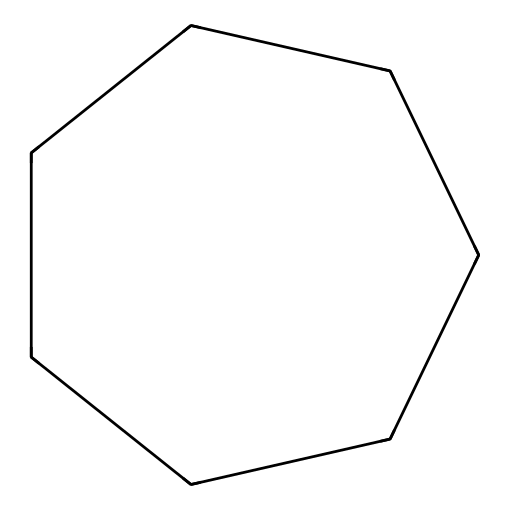What is the molecular formula for cycloheptane? The SMILES representation shows a cyclic structure with 7 carbon atoms. Each carbon typically bonds to two hydrogen atoms, except for the end carbons in a ring which are bonded to two other carbons. Therefore, the molecular formula is C7H14.
Answer: C7H14 How many carbon atoms are present in cycloheptane? The SMILES representation directly indicates 7 carbon atoms (C) in the cyclic structure.
Answer: 7 What type of chemical is cycloheptane? Cycloheptane is identified as a cycloalkane due to its cyclic structure and saturated carbon atoms, distinguishing it from alkenes or alkynes.
Answer: cycloalkane Which property distinguishes cycloheptane from linear alkanes? Cycloheptane has a ring structure, unlike linear alkanes which have a straight-chain structure. This cyclic arrangement influences its physical properties differently than linear alkanes.
Answer: ring structure How many hydrogen atoms are in cycloheptane? For cycloheptane, each of the 7 carbons with a saturated structure has enough hydrogens to satisfy carbon valency; thus it results in 14 hydrogen atoms.
Answer: 14 What is the significance of cycloheptane in agricultural applications? Cycloheptane is significant due to its favorable physical and chemical properties, which can enhance the effectiveness of pesticide formulations, contributing to better distribution and adherence on crops.
Answer: pesticide formulations 